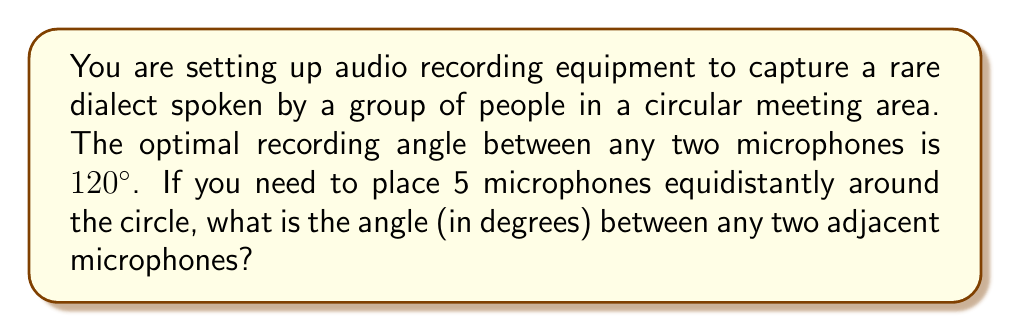What is the answer to this math problem? Let's approach this step-by-step:

1) In a circle, the total angle at the center is 360°.

2) We need to divide this total angle equally among the 5 microphones.

3) Let $\theta$ be the angle between any two adjacent microphones.

4) Since there are 5 microphones, we can set up the equation:

   $$5\theta = 360°$$

5) Solving for $\theta$:

   $$\theta = \frac{360°}{5} = 72°$$

6) We can verify this result:
   - With 5 microphones at 72° apart, the total angle covered is:
     $$5 \times 72° = 360°$$
   - This indeed completes the full circle.

7) To check the optimal recording angle condition:
   - The angle between any two non-adjacent microphones will be:
     $$72° \times 2 = 144°$$
   - This is greater than the required 120°, ensuring optimal coverage.

[asy]
unitsize(2cm);
draw(circle((0,0),1));
for(int i=0; i<5; ++i) {
  dot(dir(i*72));
  draw(dir(i*72)--origin);
}
label("72°", (0.3,0.3));
[/asy]
Answer: 72° 